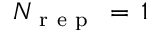<formula> <loc_0><loc_0><loc_500><loc_500>N _ { r e p } \, = \, 1</formula> 